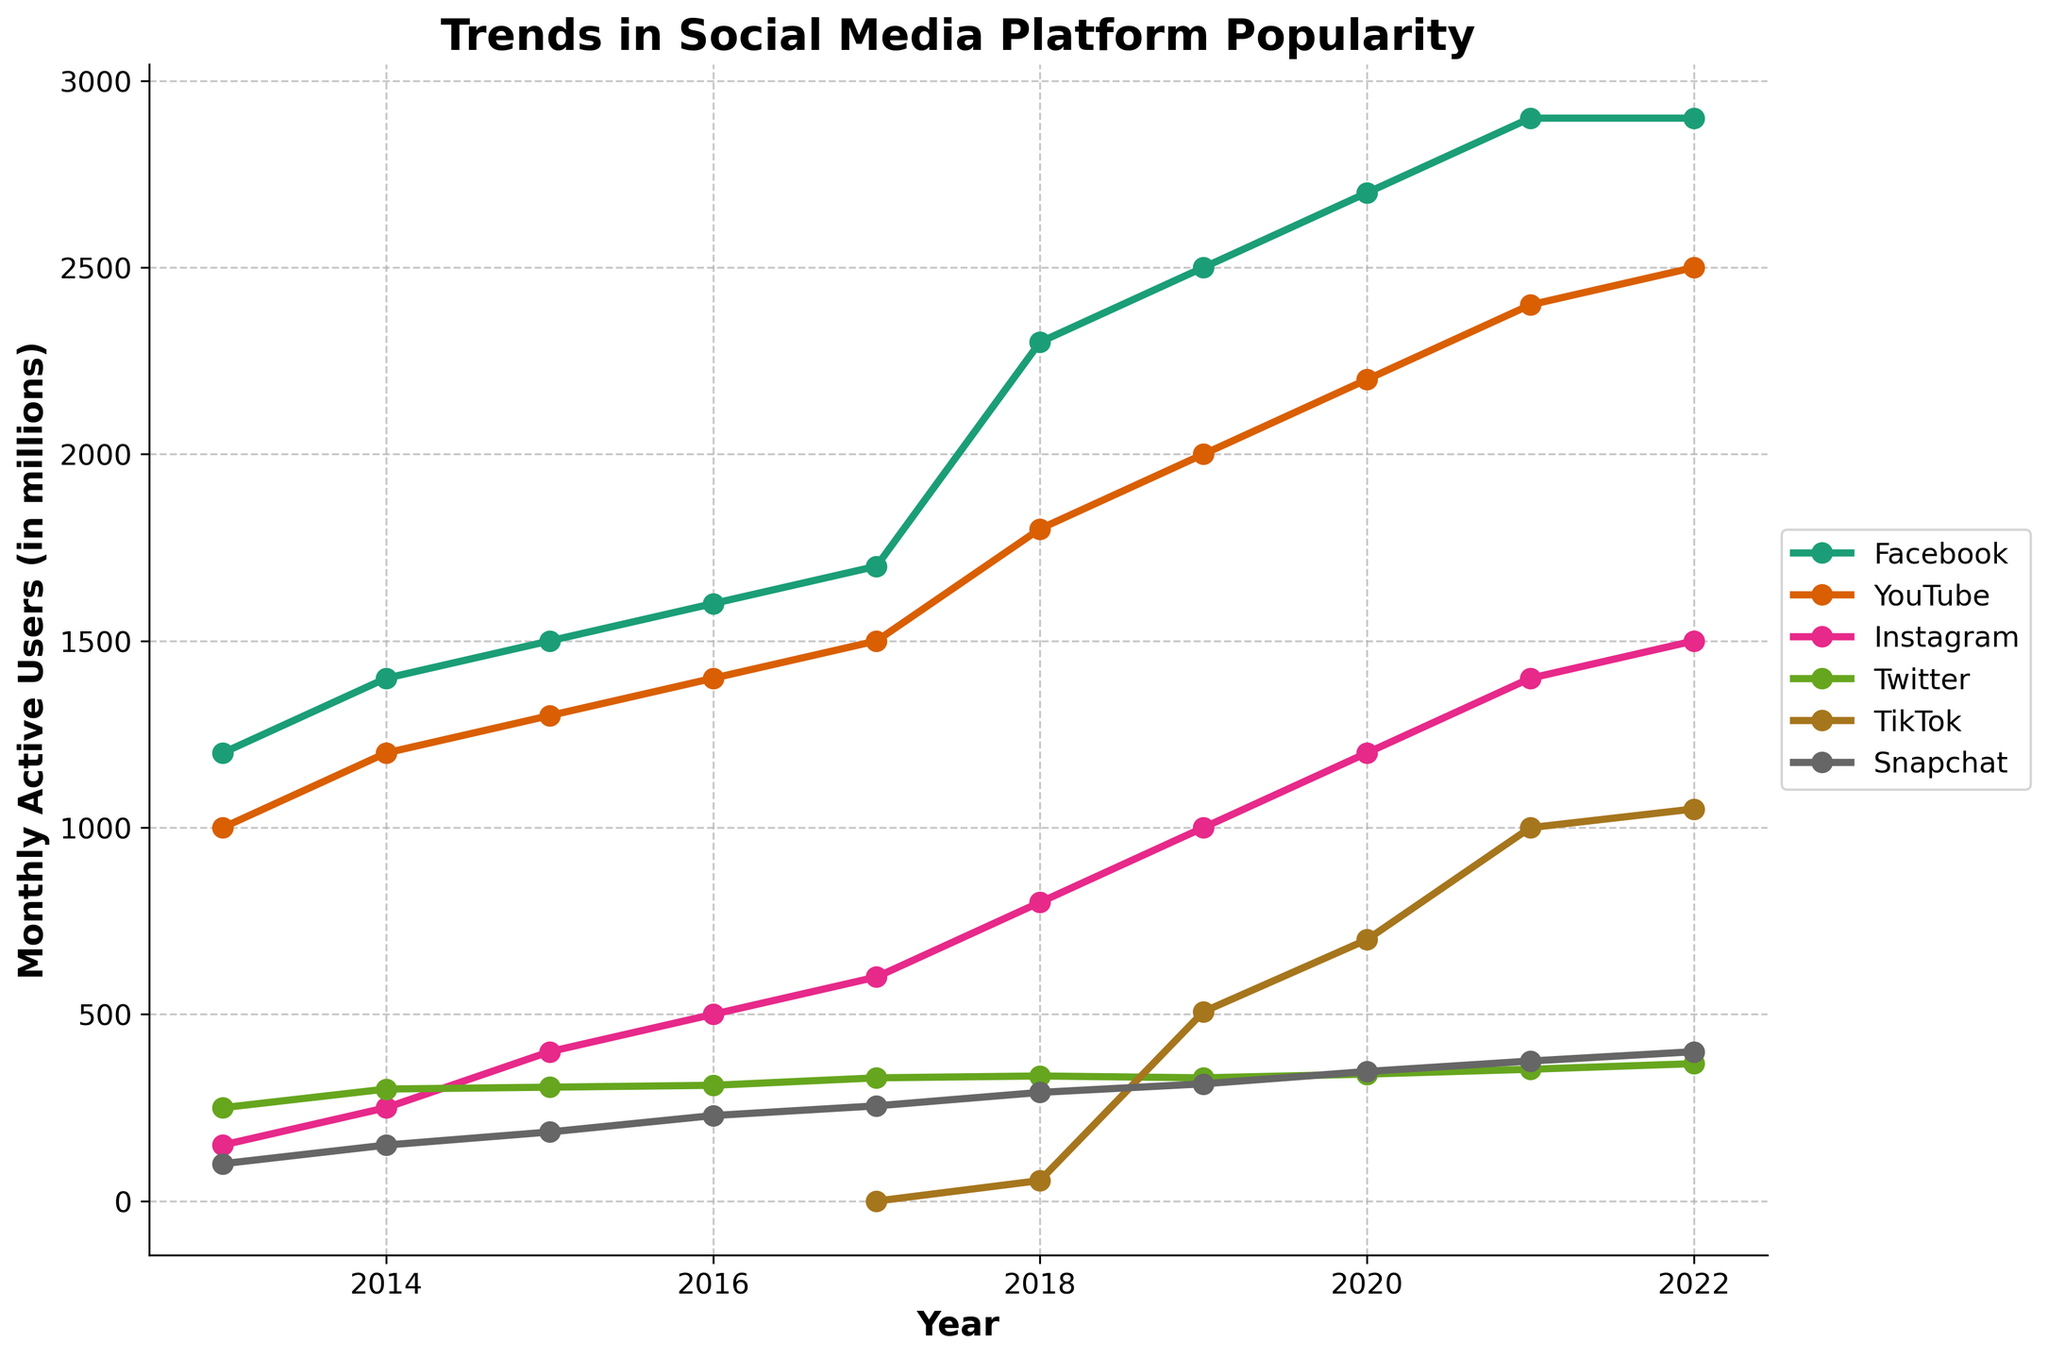What is the title of the time series plot? The title is located at the top of the plot. It is the main heading that describes the overall content of the plot.
Answer: Trends in Social Media Platform Popularity Which social media platform had the most monthly active users in 2022? Look at the endpoints of the series for the year 2022 and compare the values. The platform with the highest value is the answer.
Answer: Facebook How did TikTok's user base change between 2017 and 2022? Check the starting (2017) and ending points (2022) for the TikTok series and observe the increase in monthly active users from 0 in 2017 to 1,050 million in 2022.
Answer: Increased significantly from 0 to 1,050 million Which platform experienced the biggest increase in monthly active users between 2013 and 2022? Calculate the difference between the values in 2013 and 2022 for each platform and identify the one with the greatest change.
Answer: Facebook What's the trend in YouTube's monthly active users from 2013 to 2022? Observe the line corresponding to YouTube and note the general direction and steepness of the increase over the years.
Answer: Increasing steadily How do the growth trends of Snapchat and Twitter compare from 2013 to 2022? Compare the slopes of the lines for Snapchat and Twitter and note the differences in the rates of increase over the years.
Answer: Snapchat experienced sharper growth than Twitter In which year did Instagram surpass 1 billion monthly active users? Identify the point on Instagram's line where the value crosses 1 billion and note the corresponding year.
Answer: 2019 What is the difference in monthly active users between Facebook and Twitter in 2020? Locate the values for Facebook and Twitter in the year 2020 and subtract the number of Twitter users from the number of Facebook users.
Answer: 2,360 million Which platform had the least growth in terms of monthly active users from 2013 to 2022? Identify the platform with the smallest difference between its 2013 and 2022 values.
Answer: Twitter What was the average number of monthly active users for Instagram in 2020 and 2022? Add the values for Instagram in 2020 and 2022, then divide by 2 to find the average.
Answer: 1,350 million 